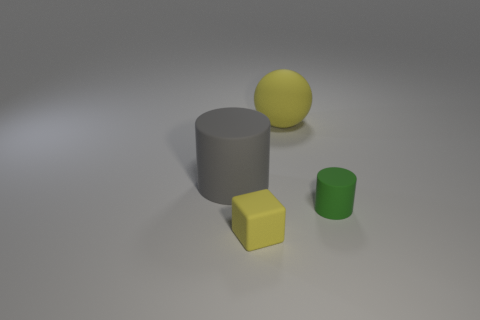Add 2 tiny shiny balls. How many objects exist? 6 Subtract all spheres. How many objects are left? 3 Add 3 rubber cylinders. How many rubber cylinders are left? 5 Add 4 yellow objects. How many yellow objects exist? 6 Subtract 1 gray cylinders. How many objects are left? 3 Subtract all tiny matte objects. Subtract all gray things. How many objects are left? 1 